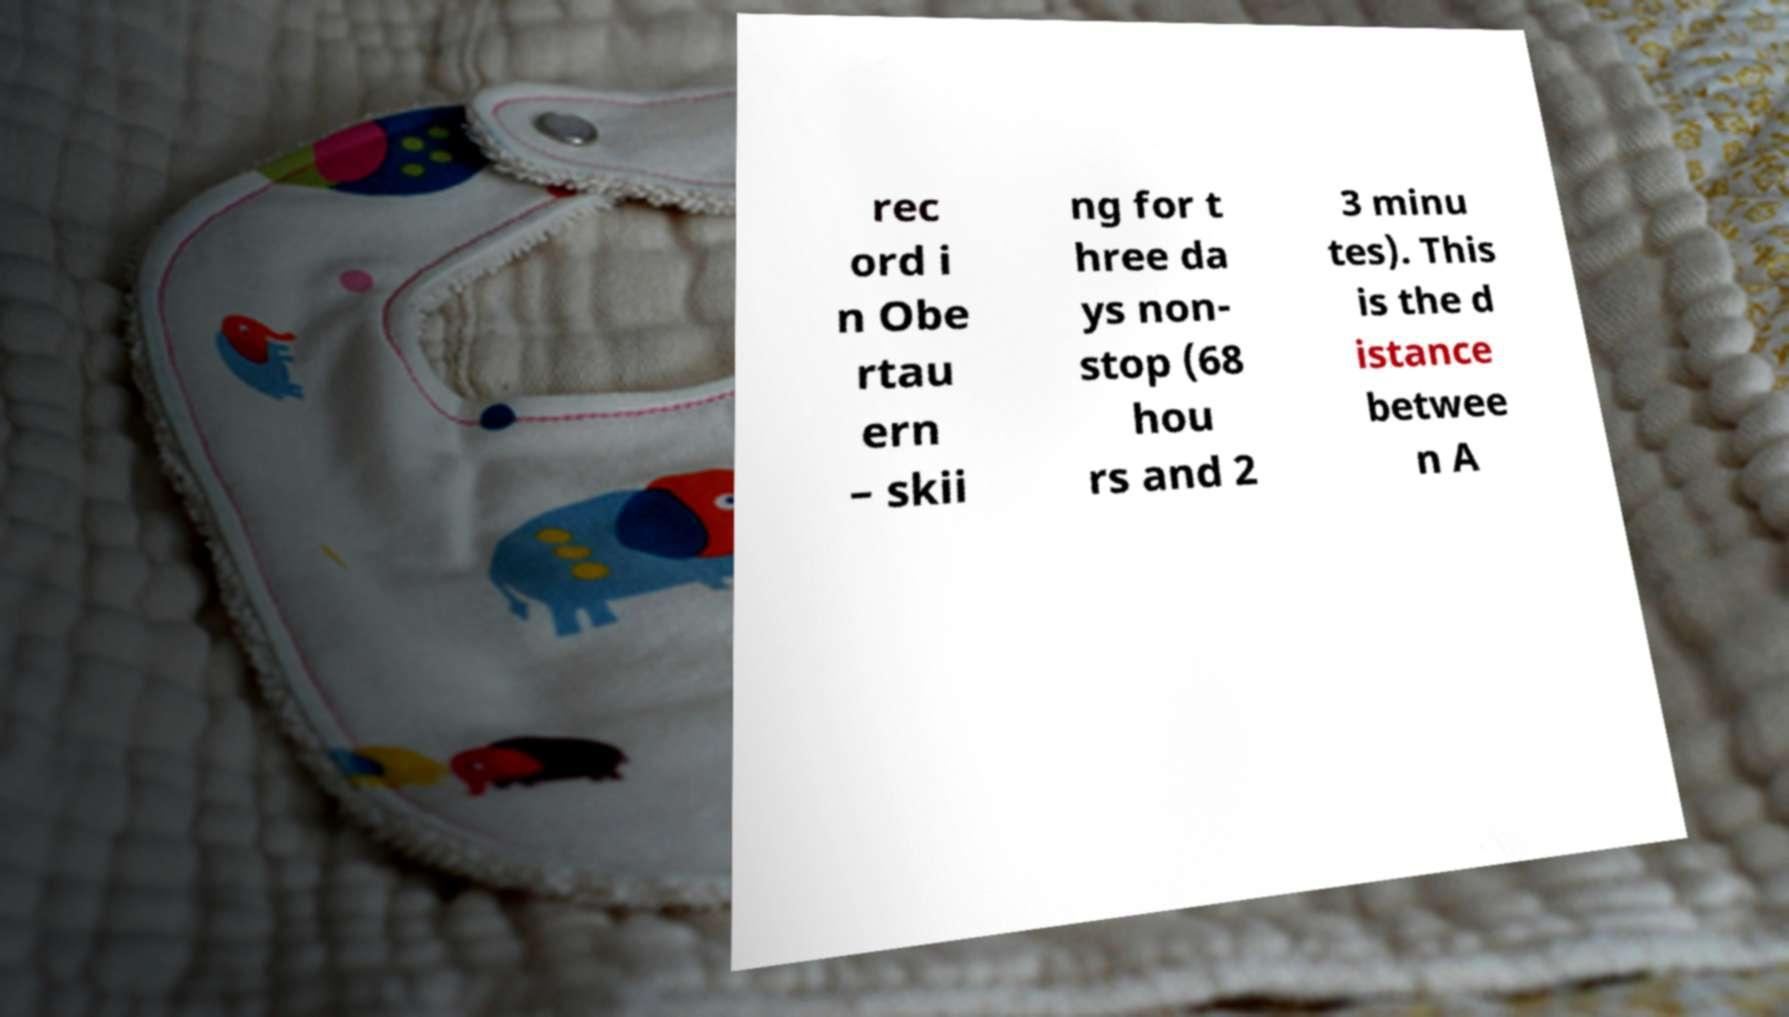Please read and relay the text visible in this image. What does it say? rec ord i n Obe rtau ern – skii ng for t hree da ys non- stop (68 hou rs and 2 3 minu tes). This is the d istance betwee n A 